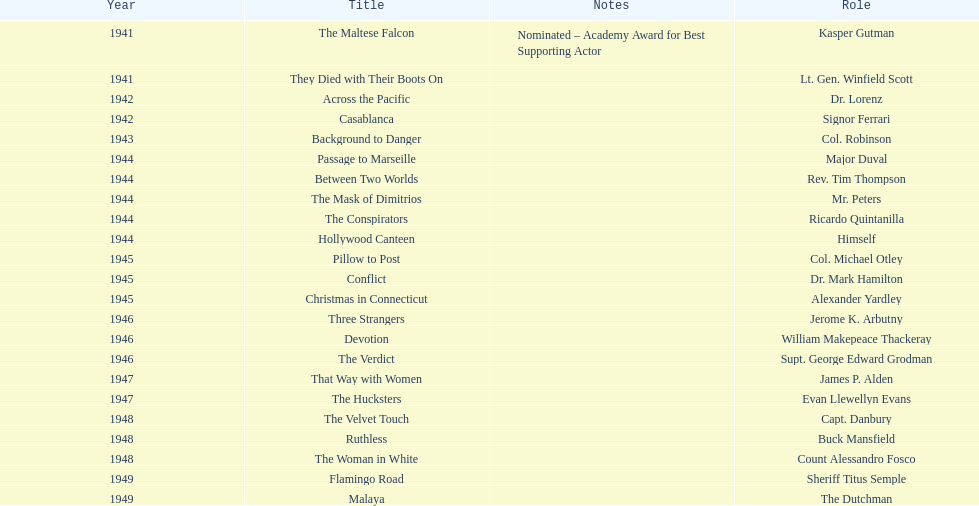Which movie did he get nominated for an oscar for? The Maltese Falcon. 